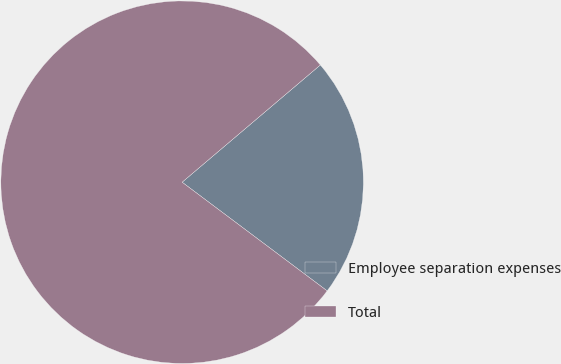<chart> <loc_0><loc_0><loc_500><loc_500><pie_chart><fcel>Employee separation expenses<fcel>Total<nl><fcel>21.43%<fcel>78.57%<nl></chart> 